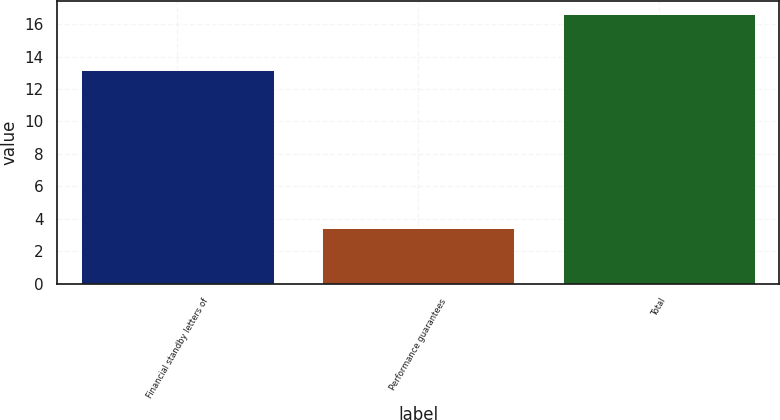<chart> <loc_0><loc_0><loc_500><loc_500><bar_chart><fcel>Financial standby letters of<fcel>Performance guarantees<fcel>Total<nl><fcel>13.2<fcel>3.4<fcel>16.6<nl></chart> 